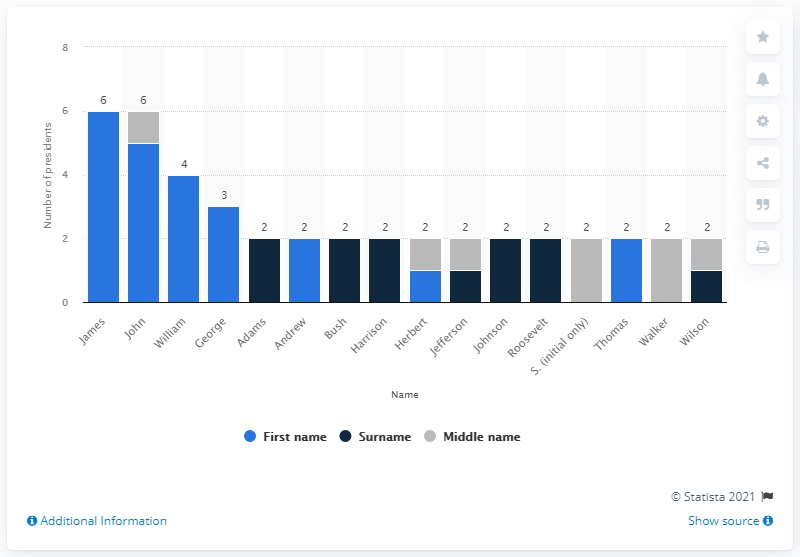Can you explain why the name 'John' has been a popular choice for U.S. presidents? The name 'John' was a popular choice for U.S. presidents, likely due to its biblical origins and common usage in English-speaking countries, particularly during the eras when these presidents were born. It is a name that was associated with strong traditional values and leadership, contributing to its choice among presidential families. Who were the presidents named John? The U.S. presidents named John include John Adams, John Quincy Adams, John Tyler, John Kennedy (commonly known as JFK), and John Johnson (Lyndon B. Johnson, who commonly went by his initials LBJ). Each brought their own distinct leadership and policies to the presidency, shaping American history in unique ways. 